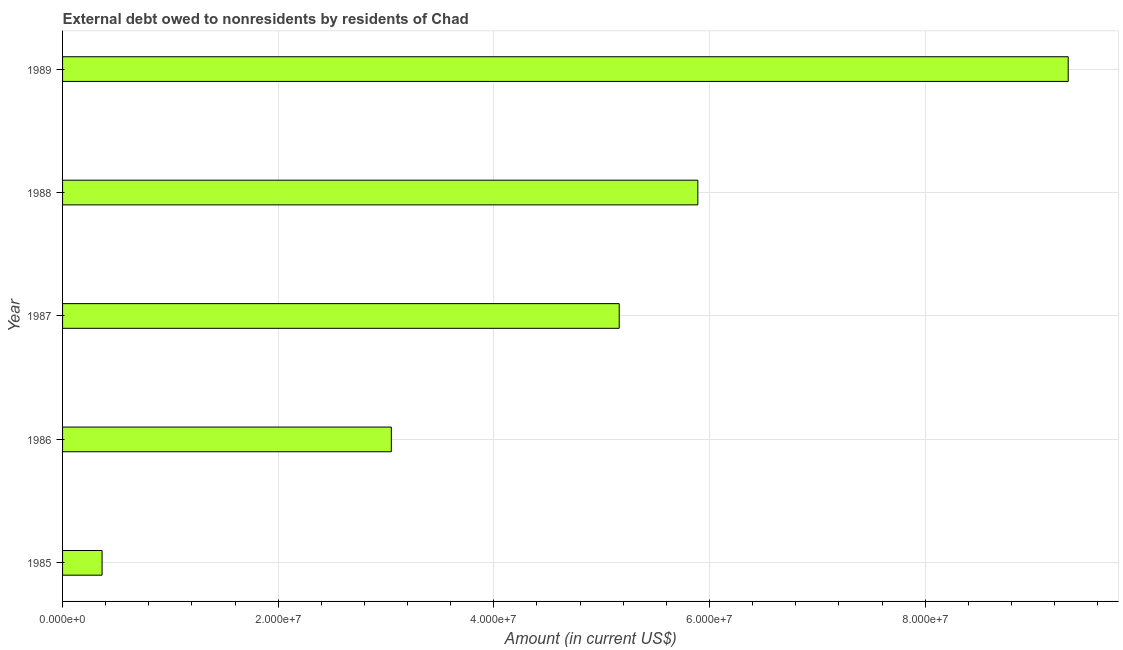What is the title of the graph?
Your answer should be compact. External debt owed to nonresidents by residents of Chad. What is the label or title of the X-axis?
Give a very brief answer. Amount (in current US$). What is the debt in 1988?
Give a very brief answer. 5.89e+07. Across all years, what is the maximum debt?
Provide a succinct answer. 9.33e+07. Across all years, what is the minimum debt?
Ensure brevity in your answer.  3.66e+06. In which year was the debt minimum?
Offer a very short reply. 1985. What is the sum of the debt?
Make the answer very short. 2.38e+08. What is the difference between the debt in 1988 and 1989?
Your answer should be compact. -3.43e+07. What is the average debt per year?
Ensure brevity in your answer.  4.76e+07. What is the median debt?
Your answer should be very brief. 5.16e+07. In how many years, is the debt greater than 32000000 US$?
Give a very brief answer. 3. What is the ratio of the debt in 1985 to that in 1989?
Offer a terse response. 0.04. What is the difference between the highest and the second highest debt?
Offer a terse response. 3.43e+07. Is the sum of the debt in 1986 and 1987 greater than the maximum debt across all years?
Provide a succinct answer. No. What is the difference between the highest and the lowest debt?
Offer a terse response. 8.96e+07. In how many years, is the debt greater than the average debt taken over all years?
Your answer should be very brief. 3. Are all the bars in the graph horizontal?
Keep it short and to the point. Yes. How many years are there in the graph?
Give a very brief answer. 5. What is the Amount (in current US$) in 1985?
Offer a very short reply. 3.66e+06. What is the Amount (in current US$) in 1986?
Make the answer very short. 3.05e+07. What is the Amount (in current US$) of 1987?
Offer a very short reply. 5.16e+07. What is the Amount (in current US$) of 1988?
Provide a succinct answer. 5.89e+07. What is the Amount (in current US$) in 1989?
Your answer should be compact. 9.33e+07. What is the difference between the Amount (in current US$) in 1985 and 1986?
Make the answer very short. -2.68e+07. What is the difference between the Amount (in current US$) in 1985 and 1987?
Keep it short and to the point. -4.80e+07. What is the difference between the Amount (in current US$) in 1985 and 1988?
Your response must be concise. -5.53e+07. What is the difference between the Amount (in current US$) in 1985 and 1989?
Give a very brief answer. -8.96e+07. What is the difference between the Amount (in current US$) in 1986 and 1987?
Offer a terse response. -2.11e+07. What is the difference between the Amount (in current US$) in 1986 and 1988?
Your answer should be very brief. -2.84e+07. What is the difference between the Amount (in current US$) in 1986 and 1989?
Provide a short and direct response. -6.28e+07. What is the difference between the Amount (in current US$) in 1987 and 1988?
Your answer should be very brief. -7.29e+06. What is the difference between the Amount (in current US$) in 1987 and 1989?
Keep it short and to the point. -4.16e+07. What is the difference between the Amount (in current US$) in 1988 and 1989?
Ensure brevity in your answer.  -3.43e+07. What is the ratio of the Amount (in current US$) in 1985 to that in 1986?
Keep it short and to the point. 0.12. What is the ratio of the Amount (in current US$) in 1985 to that in 1987?
Offer a very short reply. 0.07. What is the ratio of the Amount (in current US$) in 1985 to that in 1988?
Ensure brevity in your answer.  0.06. What is the ratio of the Amount (in current US$) in 1985 to that in 1989?
Your answer should be compact. 0.04. What is the ratio of the Amount (in current US$) in 1986 to that in 1987?
Provide a succinct answer. 0.59. What is the ratio of the Amount (in current US$) in 1986 to that in 1988?
Your answer should be compact. 0.52. What is the ratio of the Amount (in current US$) in 1986 to that in 1989?
Your response must be concise. 0.33. What is the ratio of the Amount (in current US$) in 1987 to that in 1988?
Ensure brevity in your answer.  0.88. What is the ratio of the Amount (in current US$) in 1987 to that in 1989?
Make the answer very short. 0.55. What is the ratio of the Amount (in current US$) in 1988 to that in 1989?
Offer a very short reply. 0.63. 